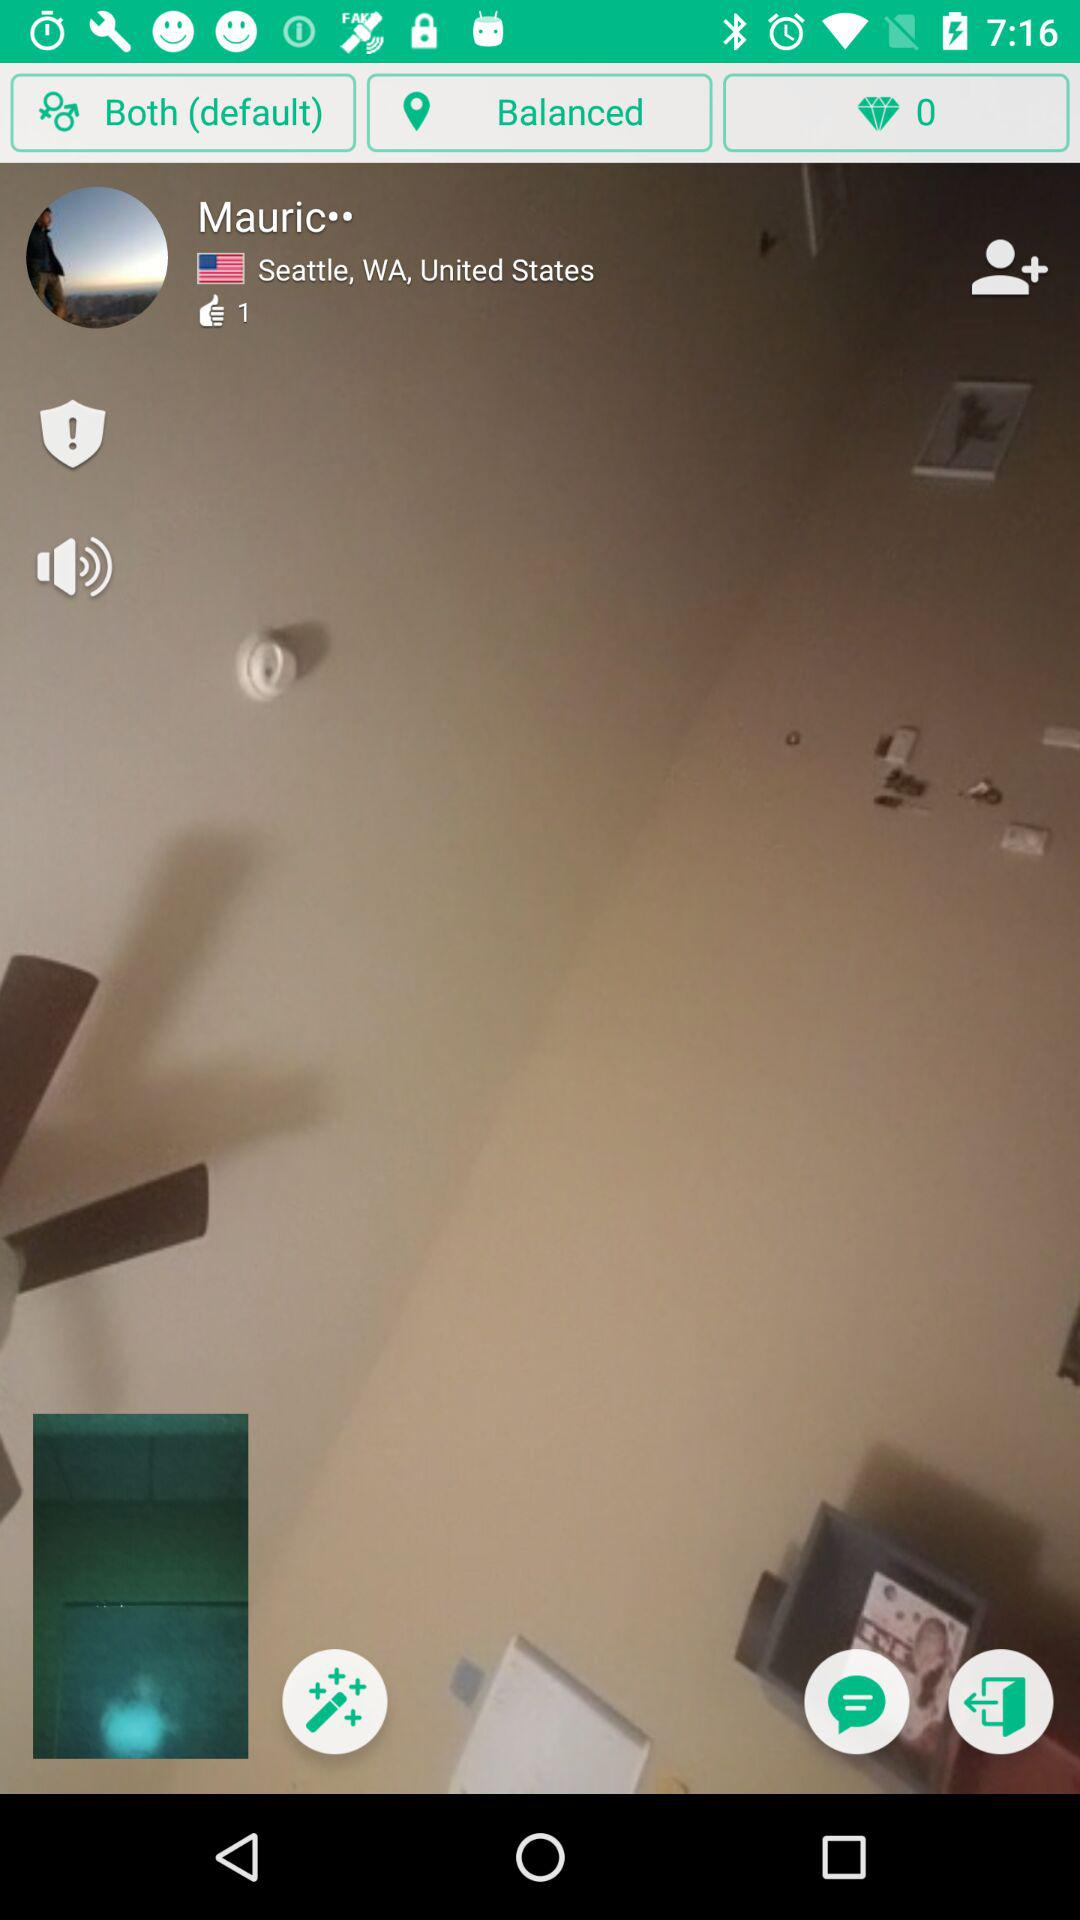What is the mentioned country? The country is the United States. 